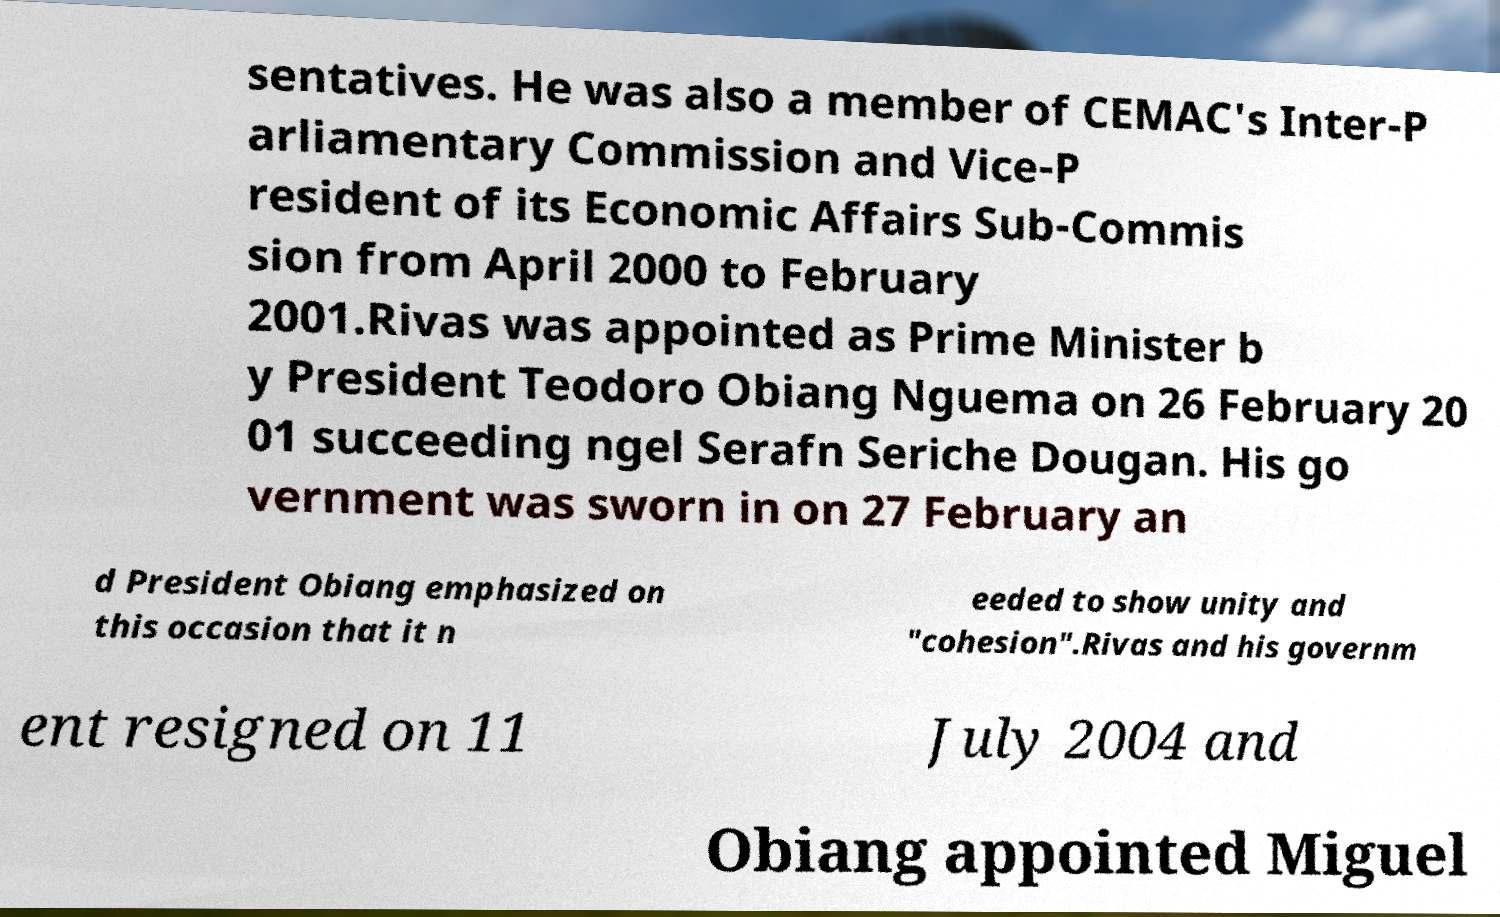There's text embedded in this image that I need extracted. Can you transcribe it verbatim? sentatives. He was also a member of CEMAC's Inter-P arliamentary Commission and Vice-P resident of its Economic Affairs Sub-Commis sion from April 2000 to February 2001.Rivas was appointed as Prime Minister b y President Teodoro Obiang Nguema on 26 February 20 01 succeeding ngel Serafn Seriche Dougan. His go vernment was sworn in on 27 February an d President Obiang emphasized on this occasion that it n eeded to show unity and "cohesion".Rivas and his governm ent resigned on 11 July 2004 and Obiang appointed Miguel 